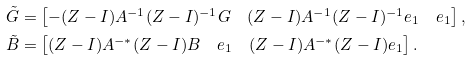Convert formula to latex. <formula><loc_0><loc_0><loc_500><loc_500>\tilde { G } & = \begin{bmatrix} - ( Z - I ) A ^ { - 1 } ( Z - I ) ^ { - 1 } G & ( Z - I ) A ^ { - 1 } ( Z - I ) ^ { - 1 } e _ { 1 } & e _ { 1 } \end{bmatrix} , \\ \tilde { B } & = \begin{bmatrix} ( Z - I ) A ^ { - * } ( Z - I ) B & e _ { 1 } & ( Z - I ) A ^ { - * } ( Z - I ) e _ { 1 } \end{bmatrix} .</formula> 